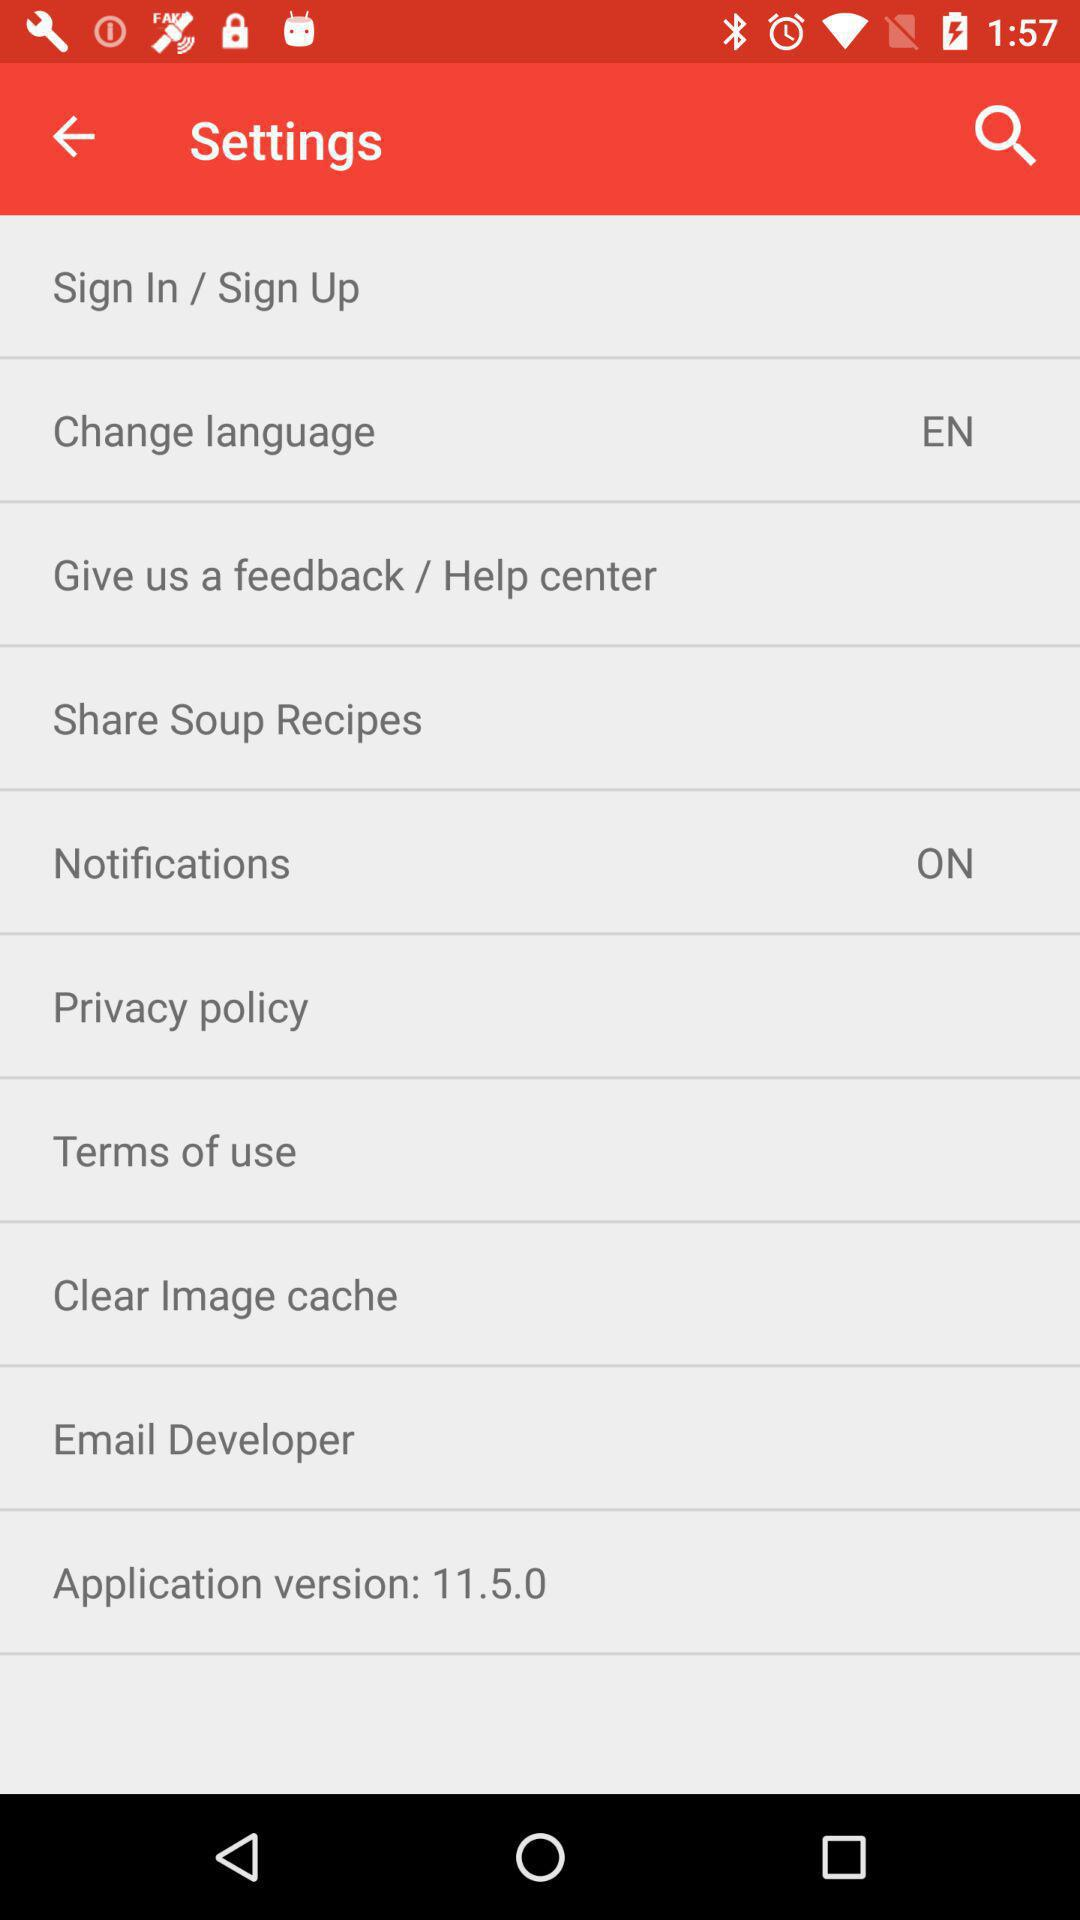What is the version of this application? The version of this application is 11.5.0. 